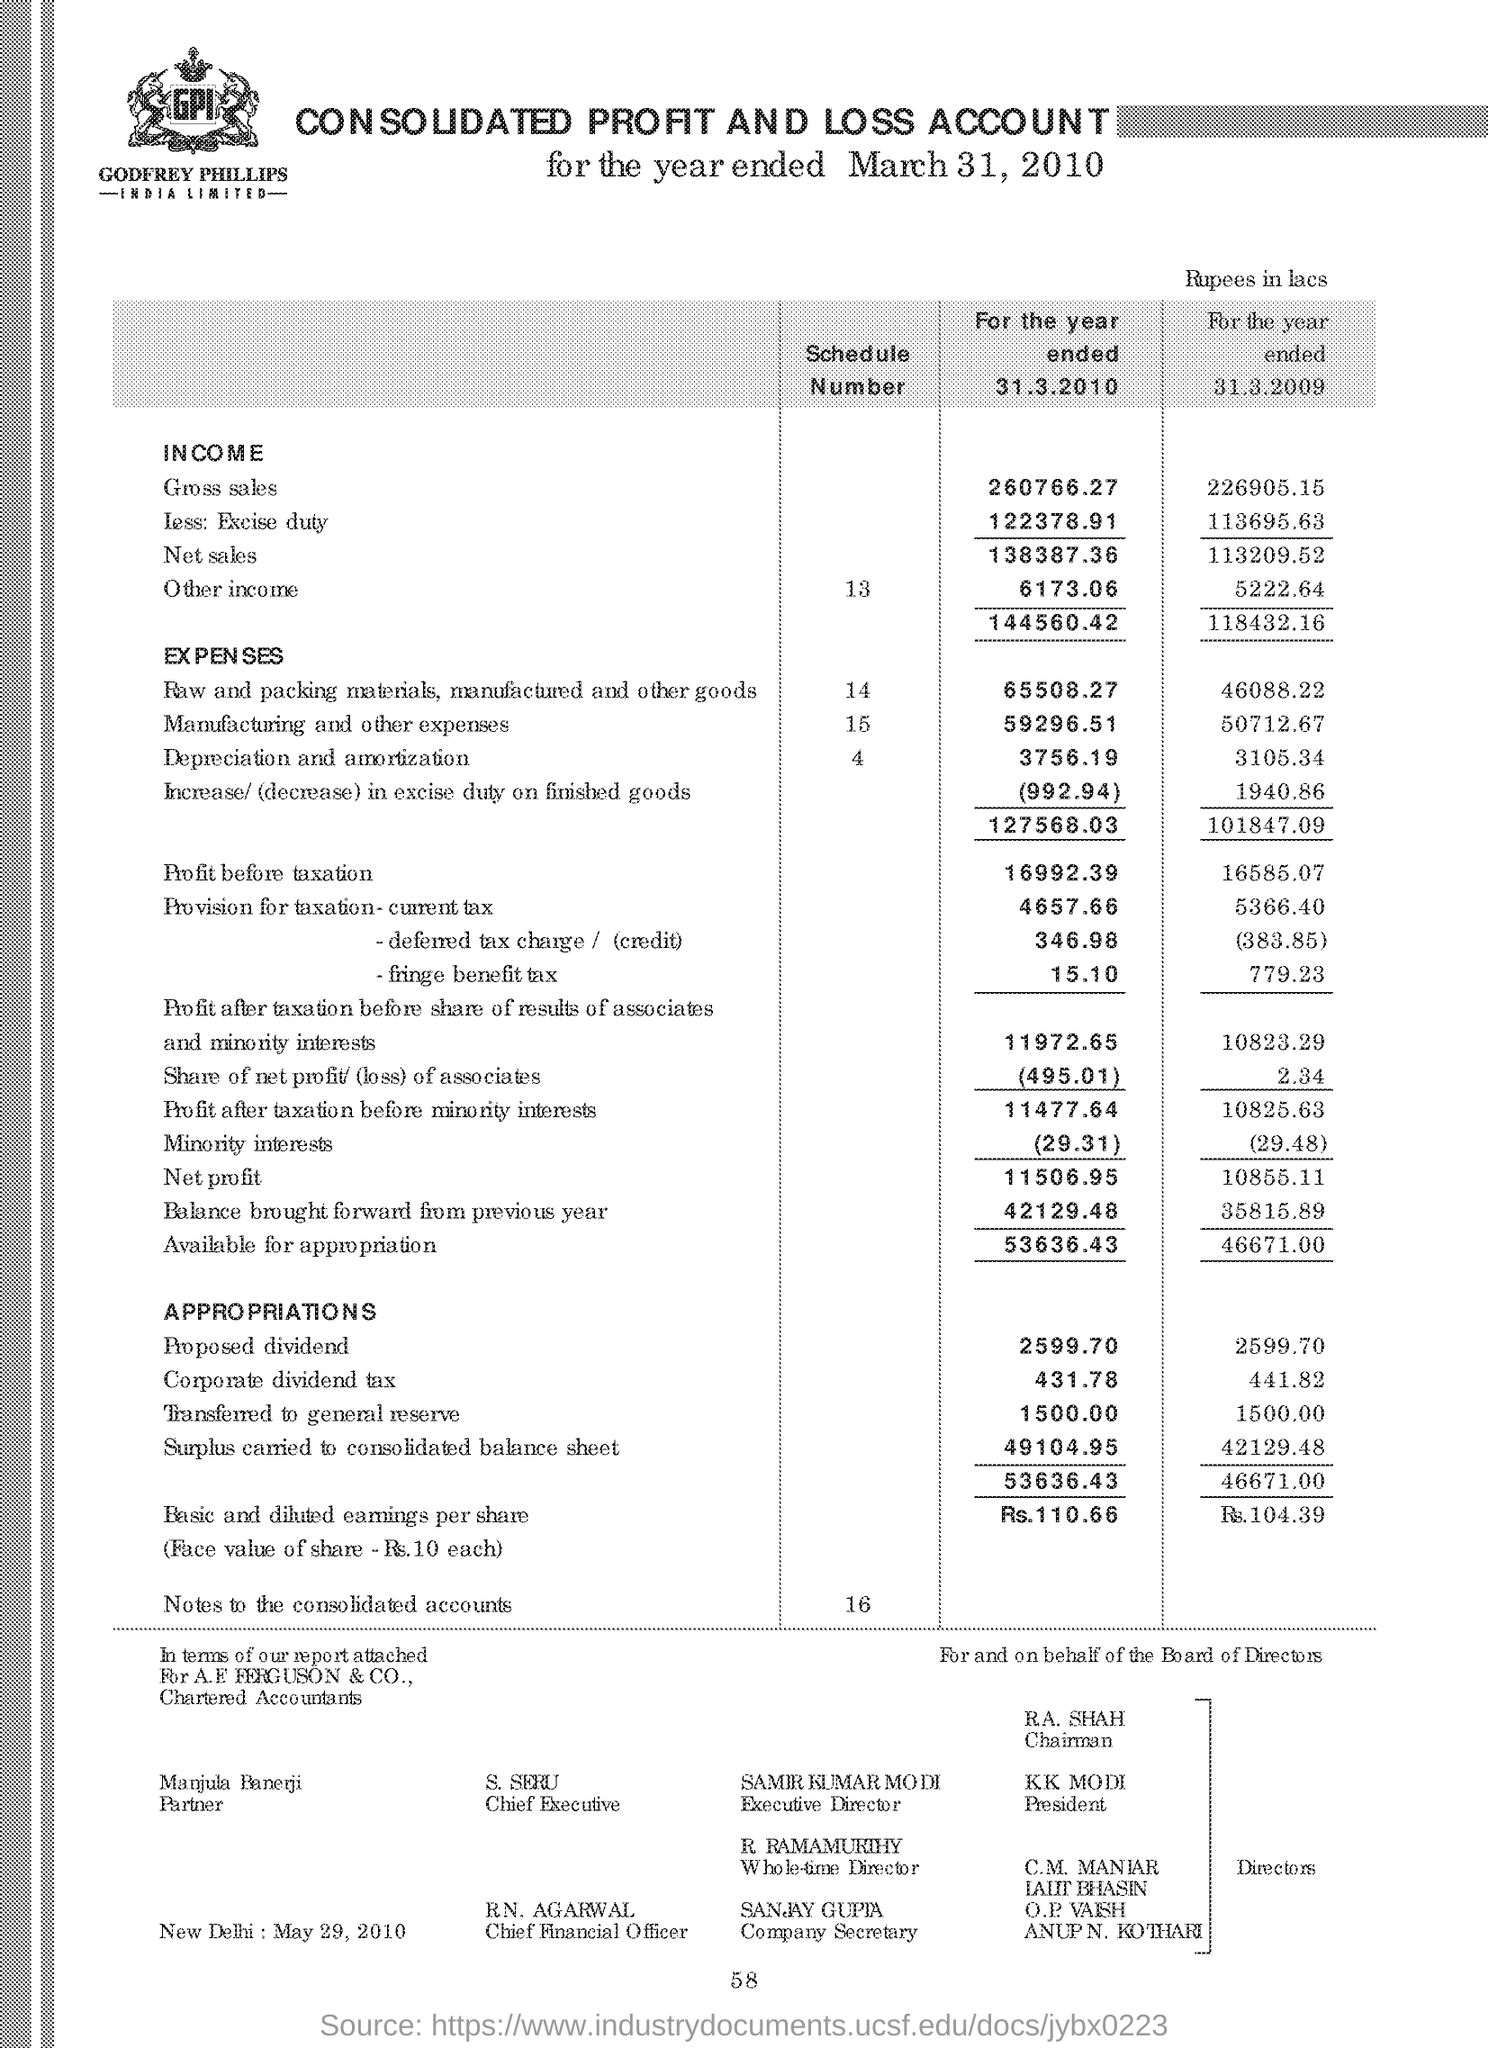Identify some key points in this picture. The company secretary is Sanjay Gupta, as indicated on the page. The schedule number of manufacturing and other expenses as shown in the account is 15. 